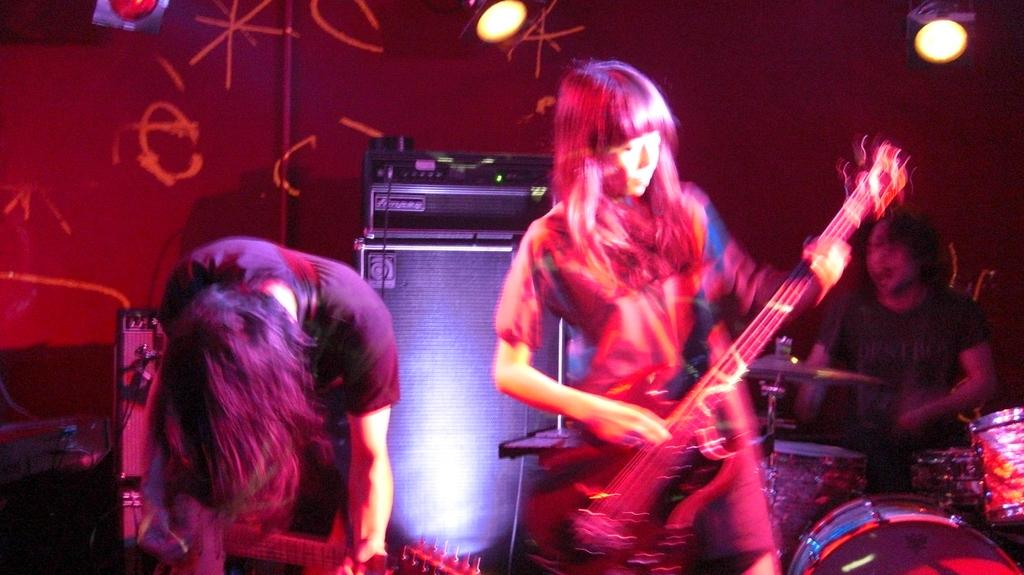What is the woman in the image doing? The woman is playing a guitar in the image. What can be seen in the background of the image? There is light visible in the background of the image. Are there any other musicians in the image? Yes, there is a person playing a drum in the image. What type of approval is the woman seeking from the audience in the image? There is no indication in the image that the woman is seeking approval from an audience, as she is simply playing the guitar. 